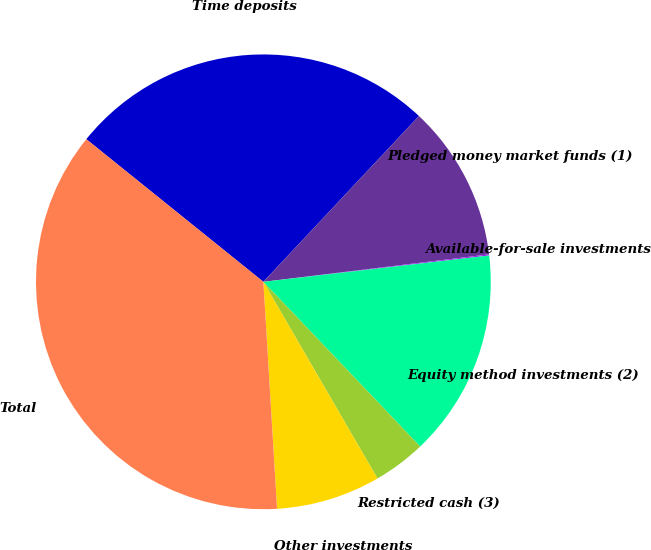Convert chart to OTSL. <chart><loc_0><loc_0><loc_500><loc_500><pie_chart><fcel>Time deposits<fcel>Pledged money market funds (1)<fcel>Available-for-sale investments<fcel>Equity method investments (2)<fcel>Restricted cash (3)<fcel>Other investments<fcel>Total<nl><fcel>26.2%<fcel>11.08%<fcel>0.08%<fcel>14.74%<fcel>3.74%<fcel>7.41%<fcel>36.75%<nl></chart> 